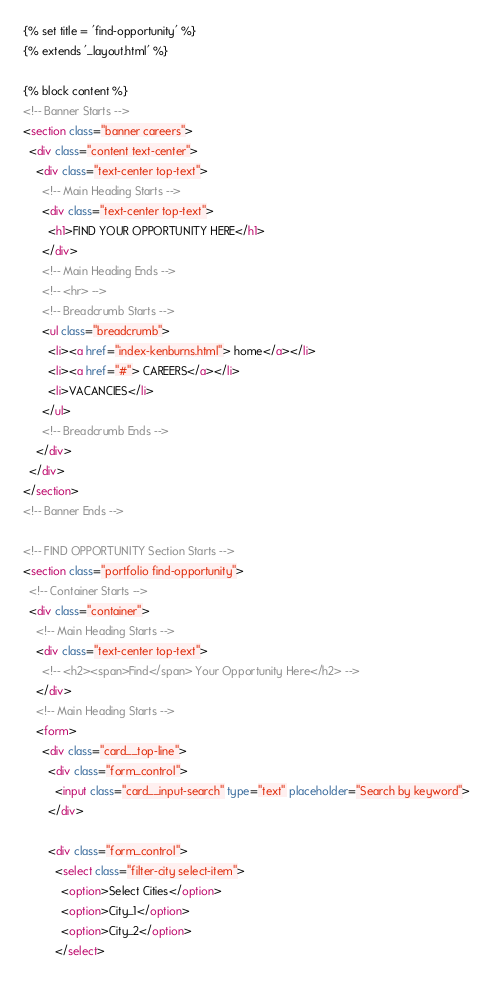<code> <loc_0><loc_0><loc_500><loc_500><_HTML_>{% set title = 'find-opportunity' %}
{% extends '_layout.html' %}

{% block content %}
<!-- Banner Starts -->
<section class="banner careers">
  <div class="content text-center">
    <div class="text-center top-text">
      <!-- Main Heading Starts -->
      <div class="text-center top-text">
        <h1>FIND YOUR OPPORTUNITY HERE</h1>
      </div>
      <!-- Main Heading Ends -->
      <!-- <hr> -->
      <!-- Breadcrumb Starts -->
      <ul class="breadcrumb">
        <li><a href="index-kenburns.html"> home</a></li>
        <li><a href="#"> CAREERS</a></li>
        <li>VACANCIES</li>
      </ul>
      <!-- Breadcrumb Ends -->
    </div>
  </div>
</section>
<!-- Banner Ends -->

<!-- FIND OPPORTUNITY Section Starts -->
<section class="portfolio find-opportunity">
  <!-- Container Starts -->
  <div class="container">
    <!-- Main Heading Starts -->
    <div class="text-center top-text">
      <!-- <h2><span>Find</span> Your Opportunity Here</h2> -->
    </div>
    <!-- Main Heading Starts -->
    <form>
      <div class="card__top-line">
        <div class="form_control">
          <input class="card__input-search" type="text" placeholder="Search by keyword">
        </div>

        <div class="form_control">
          <select class="filter-city select-item">
            <option>Select Cities</option>
            <option>City_1</option>
            <option>City_2</option>
          </select></code> 